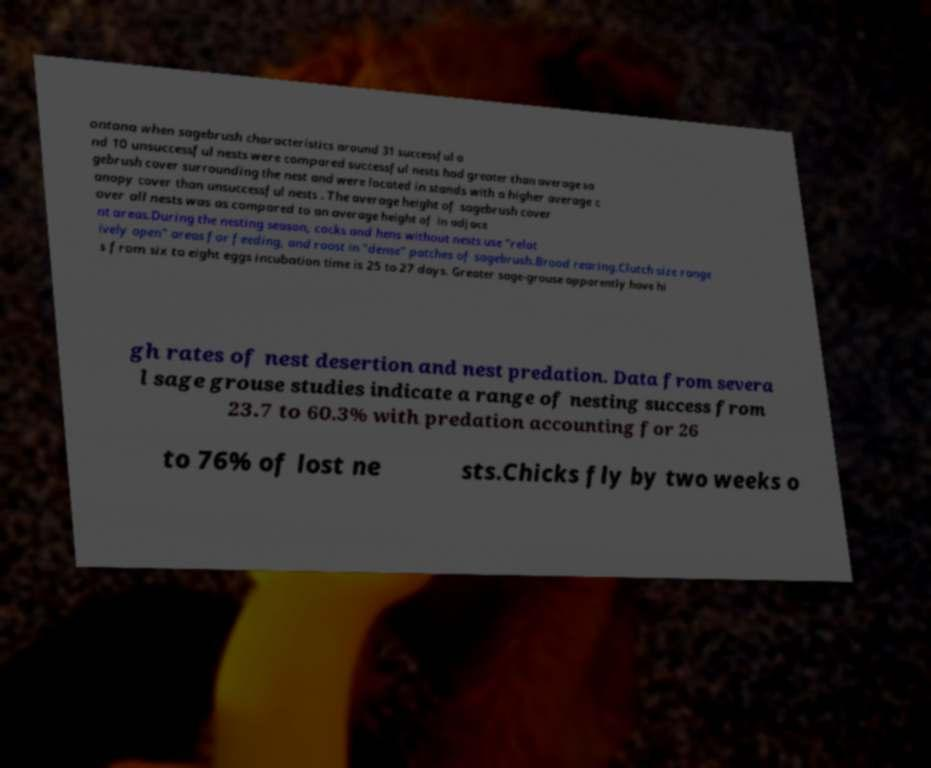Can you accurately transcribe the text from the provided image for me? ontana when sagebrush characteristics around 31 successful a nd 10 unsuccessful nests were compared successful nests had greater than average sa gebrush cover surrounding the nest and were located in stands with a higher average c anopy cover than unsuccessful nests . The average height of sagebrush cover over all nests was as compared to an average height of in adjace nt areas.During the nesting season, cocks and hens without nests use "relat ively open" areas for feeding, and roost in "dense" patches of sagebrush.Brood rearing.Clutch size range s from six to eight eggs incubation time is 25 to 27 days. Greater sage-grouse apparently have hi gh rates of nest desertion and nest predation. Data from severa l sage grouse studies indicate a range of nesting success from 23.7 to 60.3% with predation accounting for 26 to 76% of lost ne sts.Chicks fly by two weeks o 